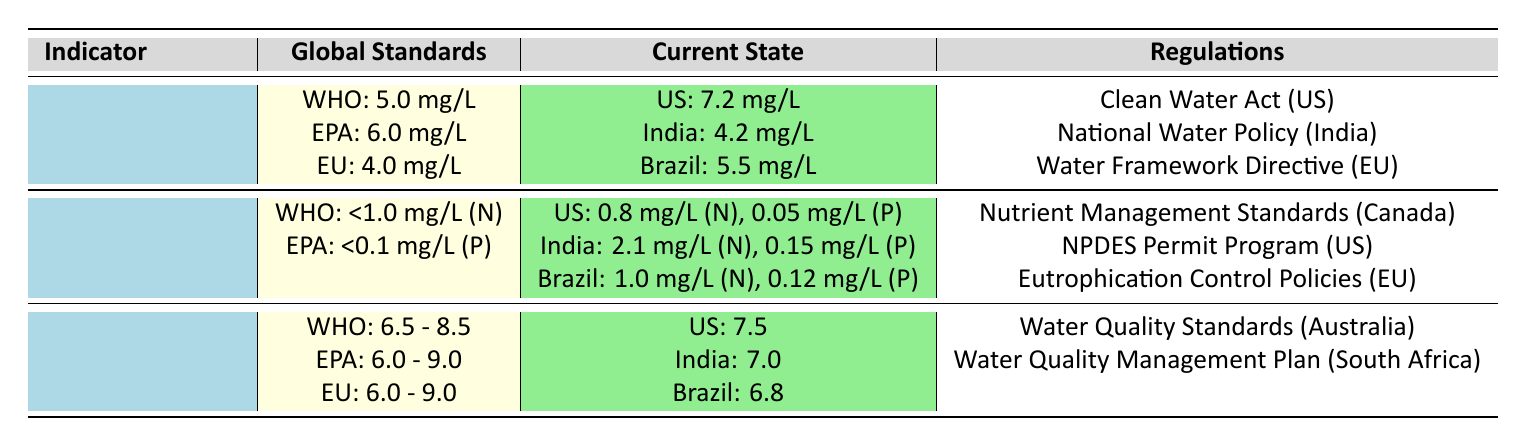What is the global standard for Dissolved Oxygen as per the WHO? The WHO standard for Dissolved Oxygen is explicitly stated in the table. Referring to the row for Dissolved Oxygen, the value listed under global standards for WHO is 5.0 mg/L.
Answer: 5.0 mg/L Which country has the highest current level of Dissolved Oxygen? The table provides the current levels of Dissolved Oxygen for three countries: United States (7.2 mg/L), India (4.2 mg/L), and Brazil (5.5 mg/L). The United States has the highest value of 7.2 mg/L.
Answer: United States Is Brazil meeting the WHO standard for Nutrient Levels for total Nitrogen? The WHO standard for total Nitrogen is less than 1.0 mg/L. Brazil has a current level of total Nitrogen at 1.0 mg/L, which does not meet the WHO standard of less than 1.0 mg/L. Therefore, Brazil is not meeting the standard.
Answer: No What is the average pH level across the current states of the United States, India, and Brazil? The pH levels provided are: United States (7.5), India (7.0), and Brazil (6.8). To find the average, we sum these values: 7.5 + 7.0 + 6.8 = 21.3. Then we divide by the number of countries (3): 21.3 / 3 = 7.1.
Answer: 7.1 Does India comply with the EPA nutrient levels regulation for phosphorus? The EPA standard for phosphorus is no more than 0.1 mg/L, and India reports a level of 0.15 mg/L. Since 0.15 mg/L exceeds the EPA limit, India does not comply.
Answer: No What rule regulates nutrient levels in Canada? The table specifies that the Nutrient Management Standards regulate nutrient loading impacting water quality in Canada. This is directly found in the regulations listed for Nutrient Levels.
Answer: Nutrient Management Standards What is the difference between the US and India's current levels of total Nitrogen? The current level of total Nitrogen in the US is 0.8 mg/L and in India is 2.1 mg/L. To find the difference, we subtract the US value from the Indian value: 2.1 - 0.8 = 1.3.
Answer: 1.3 mg/L Have any countries reached the EU's Dissolved Oxygen standard? The EU standard for Dissolved Oxygen is 4.0 mg/L. The current levels are: United States (7.2 mg/L), India (4.2 mg/L), and Brazil (5.5 mg/L). All three countries exceed the EU standard, meaning yes, they have all reached the standard.
Answer: Yes 